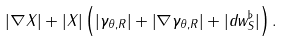Convert formula to latex. <formula><loc_0><loc_0><loc_500><loc_500>| \nabla X | + | X | \left ( \left | \gamma _ { \theta , R } \right | + \left | \nabla \gamma _ { \theta , R } \right | + | d w ^ { \flat } _ { S } | \right ) .</formula> 